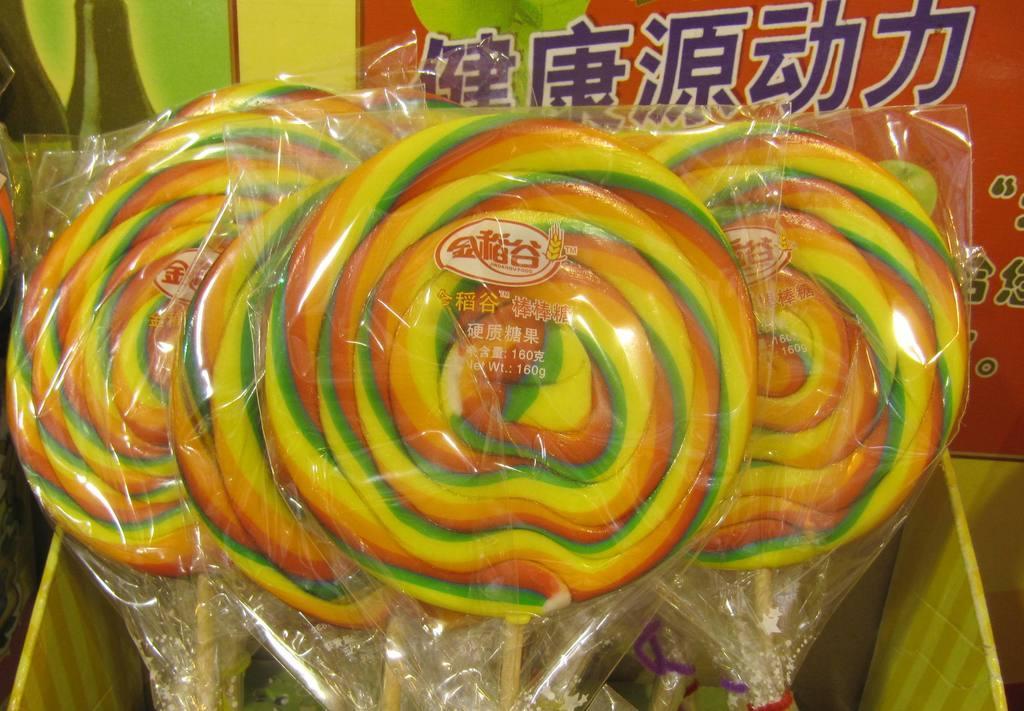Describe this image in one or two sentences. This image consists of candies. They are kept in a box. 